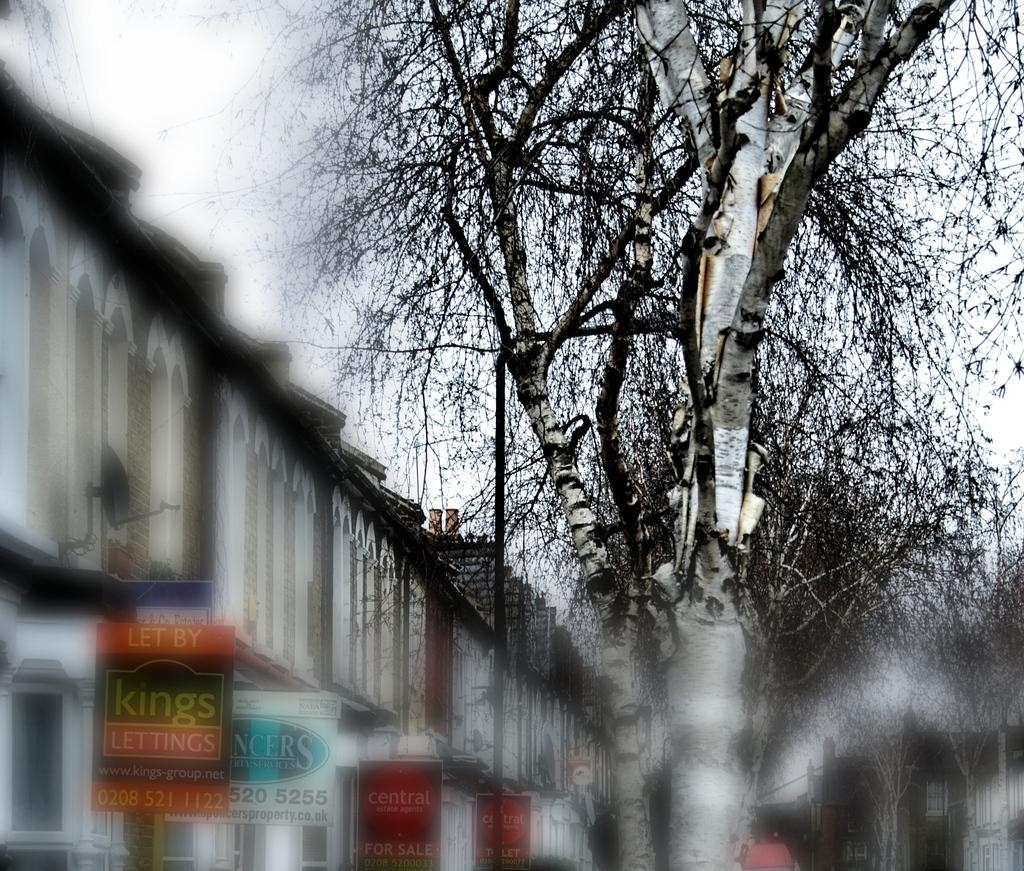<image>
Render a clear and concise summary of the photo. In front of the buildins there is a sign reading "let by kings lettings." 